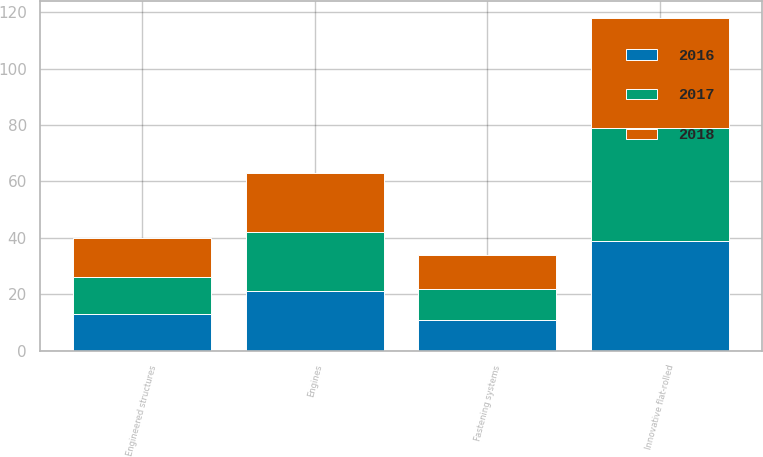Convert chart. <chart><loc_0><loc_0><loc_500><loc_500><stacked_bar_chart><ecel><fcel>Innovative flat-rolled<fcel>Engines<fcel>Engineered structures<fcel>Fastening systems<nl><fcel>2017<fcel>40<fcel>21<fcel>13<fcel>11<nl><fcel>2016<fcel>39<fcel>21<fcel>13<fcel>11<nl><fcel>2018<fcel>39<fcel>21<fcel>14<fcel>12<nl></chart> 